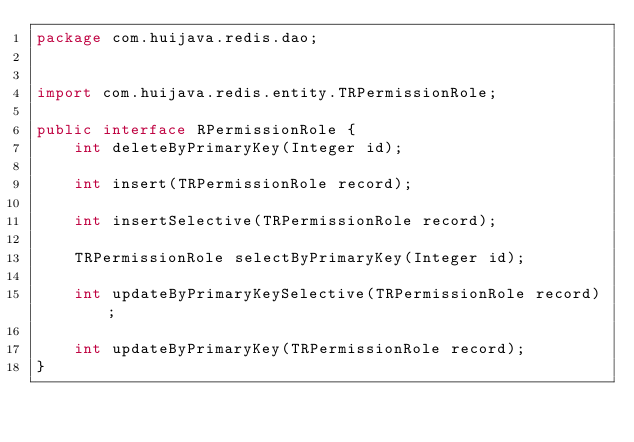Convert code to text. <code><loc_0><loc_0><loc_500><loc_500><_Java_>package com.huijava.redis.dao;


import com.huijava.redis.entity.TRPermissionRole;

public interface RPermissionRole {
    int deleteByPrimaryKey(Integer id);

    int insert(TRPermissionRole record);

    int insertSelective(TRPermissionRole record);

    TRPermissionRole selectByPrimaryKey(Integer id);

    int updateByPrimaryKeySelective(TRPermissionRole record);

    int updateByPrimaryKey(TRPermissionRole record);
}</code> 